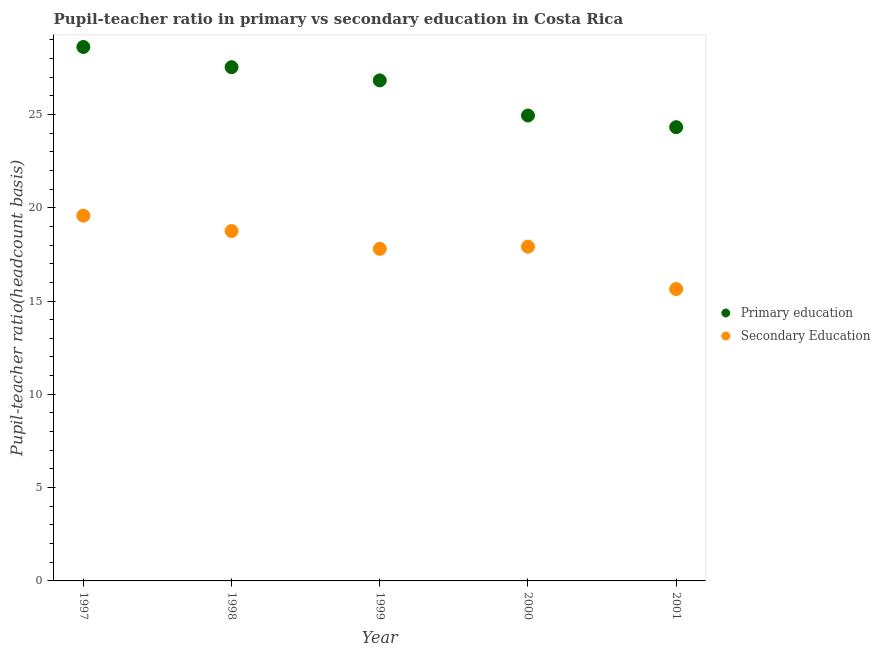Is the number of dotlines equal to the number of legend labels?
Make the answer very short. Yes. What is the pupil teacher ratio on secondary education in 2001?
Provide a succinct answer. 15.64. Across all years, what is the maximum pupil teacher ratio on secondary education?
Give a very brief answer. 19.57. Across all years, what is the minimum pupil teacher ratio on secondary education?
Your answer should be very brief. 15.64. What is the total pupil-teacher ratio in primary education in the graph?
Provide a short and direct response. 132.22. What is the difference between the pupil-teacher ratio in primary education in 1999 and that in 2001?
Give a very brief answer. 2.51. What is the difference between the pupil-teacher ratio in primary education in 1997 and the pupil teacher ratio on secondary education in 1999?
Provide a succinct answer. 10.82. What is the average pupil teacher ratio on secondary education per year?
Offer a terse response. 17.93. In the year 1999, what is the difference between the pupil teacher ratio on secondary education and pupil-teacher ratio in primary education?
Provide a succinct answer. -9.03. What is the ratio of the pupil teacher ratio on secondary education in 1997 to that in 1999?
Keep it short and to the point. 1.1. Is the pupil-teacher ratio in primary education in 1997 less than that in 1999?
Keep it short and to the point. No. What is the difference between the highest and the second highest pupil teacher ratio on secondary education?
Keep it short and to the point. 0.82. What is the difference between the highest and the lowest pupil teacher ratio on secondary education?
Provide a succinct answer. 3.93. Is the pupil teacher ratio on secondary education strictly greater than the pupil-teacher ratio in primary education over the years?
Provide a succinct answer. No. Is the pupil teacher ratio on secondary education strictly less than the pupil-teacher ratio in primary education over the years?
Ensure brevity in your answer.  Yes. How many dotlines are there?
Give a very brief answer. 2. How many years are there in the graph?
Your answer should be very brief. 5. Are the values on the major ticks of Y-axis written in scientific E-notation?
Make the answer very short. No. Does the graph contain any zero values?
Provide a short and direct response. No. Where does the legend appear in the graph?
Ensure brevity in your answer.  Center right. How are the legend labels stacked?
Provide a short and direct response. Vertical. What is the title of the graph?
Give a very brief answer. Pupil-teacher ratio in primary vs secondary education in Costa Rica. Does "Investment in Transport" appear as one of the legend labels in the graph?
Keep it short and to the point. No. What is the label or title of the Y-axis?
Your response must be concise. Pupil-teacher ratio(headcount basis). What is the Pupil-teacher ratio(headcount basis) of Primary education in 1997?
Give a very brief answer. 28.61. What is the Pupil-teacher ratio(headcount basis) in Secondary Education in 1997?
Your answer should be very brief. 19.57. What is the Pupil-teacher ratio(headcount basis) in Primary education in 1998?
Offer a very short reply. 27.53. What is the Pupil-teacher ratio(headcount basis) in Secondary Education in 1998?
Your answer should be very brief. 18.75. What is the Pupil-teacher ratio(headcount basis) of Primary education in 1999?
Provide a succinct answer. 26.82. What is the Pupil-teacher ratio(headcount basis) in Secondary Education in 1999?
Offer a terse response. 17.79. What is the Pupil-teacher ratio(headcount basis) in Primary education in 2000?
Keep it short and to the point. 24.94. What is the Pupil-teacher ratio(headcount basis) in Secondary Education in 2000?
Your answer should be very brief. 17.91. What is the Pupil-teacher ratio(headcount basis) in Primary education in 2001?
Offer a very short reply. 24.31. What is the Pupil-teacher ratio(headcount basis) of Secondary Education in 2001?
Ensure brevity in your answer.  15.64. Across all years, what is the maximum Pupil-teacher ratio(headcount basis) of Primary education?
Your answer should be compact. 28.61. Across all years, what is the maximum Pupil-teacher ratio(headcount basis) in Secondary Education?
Keep it short and to the point. 19.57. Across all years, what is the minimum Pupil-teacher ratio(headcount basis) of Primary education?
Your answer should be very brief. 24.31. Across all years, what is the minimum Pupil-teacher ratio(headcount basis) in Secondary Education?
Provide a short and direct response. 15.64. What is the total Pupil-teacher ratio(headcount basis) of Primary education in the graph?
Your answer should be very brief. 132.22. What is the total Pupil-teacher ratio(headcount basis) of Secondary Education in the graph?
Your response must be concise. 89.67. What is the difference between the Pupil-teacher ratio(headcount basis) in Primary education in 1997 and that in 1998?
Offer a terse response. 1.08. What is the difference between the Pupil-teacher ratio(headcount basis) in Secondary Education in 1997 and that in 1998?
Provide a succinct answer. 0.82. What is the difference between the Pupil-teacher ratio(headcount basis) in Primary education in 1997 and that in 1999?
Provide a short and direct response. 1.79. What is the difference between the Pupil-teacher ratio(headcount basis) in Secondary Education in 1997 and that in 1999?
Your response must be concise. 1.78. What is the difference between the Pupil-teacher ratio(headcount basis) in Primary education in 1997 and that in 2000?
Provide a short and direct response. 3.67. What is the difference between the Pupil-teacher ratio(headcount basis) in Secondary Education in 1997 and that in 2000?
Provide a short and direct response. 1.66. What is the difference between the Pupil-teacher ratio(headcount basis) of Primary education in 1997 and that in 2001?
Offer a terse response. 4.3. What is the difference between the Pupil-teacher ratio(headcount basis) in Secondary Education in 1997 and that in 2001?
Your response must be concise. 3.93. What is the difference between the Pupil-teacher ratio(headcount basis) of Primary education in 1998 and that in 1999?
Your response must be concise. 0.71. What is the difference between the Pupil-teacher ratio(headcount basis) in Secondary Education in 1998 and that in 1999?
Your answer should be very brief. 0.96. What is the difference between the Pupil-teacher ratio(headcount basis) of Primary education in 1998 and that in 2000?
Keep it short and to the point. 2.59. What is the difference between the Pupil-teacher ratio(headcount basis) of Secondary Education in 1998 and that in 2000?
Your answer should be very brief. 0.84. What is the difference between the Pupil-teacher ratio(headcount basis) of Primary education in 1998 and that in 2001?
Offer a terse response. 3.21. What is the difference between the Pupil-teacher ratio(headcount basis) in Secondary Education in 1998 and that in 2001?
Give a very brief answer. 3.11. What is the difference between the Pupil-teacher ratio(headcount basis) in Primary education in 1999 and that in 2000?
Your answer should be very brief. 1.88. What is the difference between the Pupil-teacher ratio(headcount basis) in Secondary Education in 1999 and that in 2000?
Give a very brief answer. -0.12. What is the difference between the Pupil-teacher ratio(headcount basis) in Primary education in 1999 and that in 2001?
Your answer should be very brief. 2.51. What is the difference between the Pupil-teacher ratio(headcount basis) of Secondary Education in 1999 and that in 2001?
Keep it short and to the point. 2.15. What is the difference between the Pupil-teacher ratio(headcount basis) of Primary education in 2000 and that in 2001?
Ensure brevity in your answer.  0.63. What is the difference between the Pupil-teacher ratio(headcount basis) of Secondary Education in 2000 and that in 2001?
Ensure brevity in your answer.  2.27. What is the difference between the Pupil-teacher ratio(headcount basis) of Primary education in 1997 and the Pupil-teacher ratio(headcount basis) of Secondary Education in 1998?
Your response must be concise. 9.86. What is the difference between the Pupil-teacher ratio(headcount basis) of Primary education in 1997 and the Pupil-teacher ratio(headcount basis) of Secondary Education in 1999?
Provide a short and direct response. 10.82. What is the difference between the Pupil-teacher ratio(headcount basis) of Primary education in 1997 and the Pupil-teacher ratio(headcount basis) of Secondary Education in 2000?
Ensure brevity in your answer.  10.7. What is the difference between the Pupil-teacher ratio(headcount basis) in Primary education in 1997 and the Pupil-teacher ratio(headcount basis) in Secondary Education in 2001?
Offer a very short reply. 12.97. What is the difference between the Pupil-teacher ratio(headcount basis) in Primary education in 1998 and the Pupil-teacher ratio(headcount basis) in Secondary Education in 1999?
Make the answer very short. 9.73. What is the difference between the Pupil-teacher ratio(headcount basis) in Primary education in 1998 and the Pupil-teacher ratio(headcount basis) in Secondary Education in 2000?
Your answer should be compact. 9.62. What is the difference between the Pupil-teacher ratio(headcount basis) of Primary education in 1998 and the Pupil-teacher ratio(headcount basis) of Secondary Education in 2001?
Your response must be concise. 11.89. What is the difference between the Pupil-teacher ratio(headcount basis) of Primary education in 1999 and the Pupil-teacher ratio(headcount basis) of Secondary Education in 2000?
Keep it short and to the point. 8.91. What is the difference between the Pupil-teacher ratio(headcount basis) in Primary education in 1999 and the Pupil-teacher ratio(headcount basis) in Secondary Education in 2001?
Provide a succinct answer. 11.18. What is the difference between the Pupil-teacher ratio(headcount basis) in Primary education in 2000 and the Pupil-teacher ratio(headcount basis) in Secondary Education in 2001?
Offer a terse response. 9.3. What is the average Pupil-teacher ratio(headcount basis) of Primary education per year?
Provide a succinct answer. 26.44. What is the average Pupil-teacher ratio(headcount basis) of Secondary Education per year?
Make the answer very short. 17.93. In the year 1997, what is the difference between the Pupil-teacher ratio(headcount basis) of Primary education and Pupil-teacher ratio(headcount basis) of Secondary Education?
Keep it short and to the point. 9.04. In the year 1998, what is the difference between the Pupil-teacher ratio(headcount basis) of Primary education and Pupil-teacher ratio(headcount basis) of Secondary Education?
Your answer should be compact. 8.78. In the year 1999, what is the difference between the Pupil-teacher ratio(headcount basis) in Primary education and Pupil-teacher ratio(headcount basis) in Secondary Education?
Your answer should be compact. 9.03. In the year 2000, what is the difference between the Pupil-teacher ratio(headcount basis) in Primary education and Pupil-teacher ratio(headcount basis) in Secondary Education?
Provide a short and direct response. 7.03. In the year 2001, what is the difference between the Pupil-teacher ratio(headcount basis) of Primary education and Pupil-teacher ratio(headcount basis) of Secondary Education?
Your response must be concise. 8.67. What is the ratio of the Pupil-teacher ratio(headcount basis) of Primary education in 1997 to that in 1998?
Offer a very short reply. 1.04. What is the ratio of the Pupil-teacher ratio(headcount basis) of Secondary Education in 1997 to that in 1998?
Provide a succinct answer. 1.04. What is the ratio of the Pupil-teacher ratio(headcount basis) of Primary education in 1997 to that in 1999?
Provide a short and direct response. 1.07. What is the ratio of the Pupil-teacher ratio(headcount basis) of Secondary Education in 1997 to that in 1999?
Provide a succinct answer. 1.1. What is the ratio of the Pupil-teacher ratio(headcount basis) of Primary education in 1997 to that in 2000?
Keep it short and to the point. 1.15. What is the ratio of the Pupil-teacher ratio(headcount basis) in Secondary Education in 1997 to that in 2000?
Your answer should be very brief. 1.09. What is the ratio of the Pupil-teacher ratio(headcount basis) in Primary education in 1997 to that in 2001?
Ensure brevity in your answer.  1.18. What is the ratio of the Pupil-teacher ratio(headcount basis) of Secondary Education in 1997 to that in 2001?
Keep it short and to the point. 1.25. What is the ratio of the Pupil-teacher ratio(headcount basis) of Primary education in 1998 to that in 1999?
Ensure brevity in your answer.  1.03. What is the ratio of the Pupil-teacher ratio(headcount basis) in Secondary Education in 1998 to that in 1999?
Offer a very short reply. 1.05. What is the ratio of the Pupil-teacher ratio(headcount basis) of Primary education in 1998 to that in 2000?
Make the answer very short. 1.1. What is the ratio of the Pupil-teacher ratio(headcount basis) in Secondary Education in 1998 to that in 2000?
Provide a short and direct response. 1.05. What is the ratio of the Pupil-teacher ratio(headcount basis) of Primary education in 1998 to that in 2001?
Provide a succinct answer. 1.13. What is the ratio of the Pupil-teacher ratio(headcount basis) of Secondary Education in 1998 to that in 2001?
Offer a terse response. 1.2. What is the ratio of the Pupil-teacher ratio(headcount basis) in Primary education in 1999 to that in 2000?
Offer a terse response. 1.08. What is the ratio of the Pupil-teacher ratio(headcount basis) of Secondary Education in 1999 to that in 2000?
Provide a succinct answer. 0.99. What is the ratio of the Pupil-teacher ratio(headcount basis) in Primary education in 1999 to that in 2001?
Offer a terse response. 1.1. What is the ratio of the Pupil-teacher ratio(headcount basis) in Secondary Education in 1999 to that in 2001?
Provide a short and direct response. 1.14. What is the ratio of the Pupil-teacher ratio(headcount basis) of Primary education in 2000 to that in 2001?
Keep it short and to the point. 1.03. What is the ratio of the Pupil-teacher ratio(headcount basis) of Secondary Education in 2000 to that in 2001?
Your response must be concise. 1.15. What is the difference between the highest and the second highest Pupil-teacher ratio(headcount basis) of Primary education?
Your answer should be very brief. 1.08. What is the difference between the highest and the second highest Pupil-teacher ratio(headcount basis) of Secondary Education?
Offer a very short reply. 0.82. What is the difference between the highest and the lowest Pupil-teacher ratio(headcount basis) of Primary education?
Give a very brief answer. 4.3. What is the difference between the highest and the lowest Pupil-teacher ratio(headcount basis) in Secondary Education?
Keep it short and to the point. 3.93. 